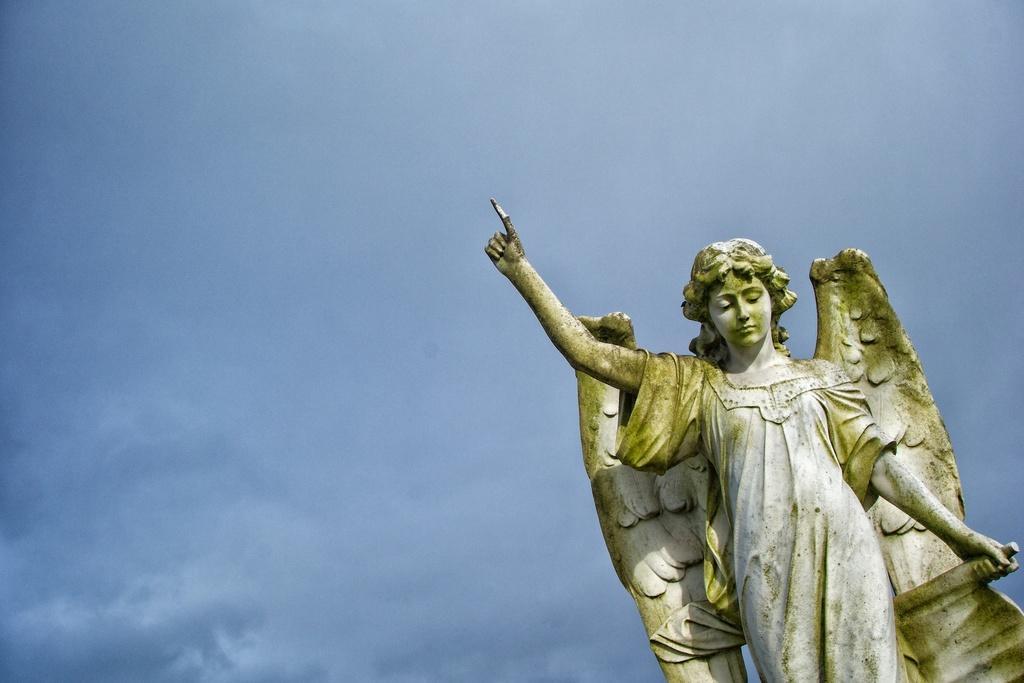Please provide a concise description of this image. In this image I can see the statue of the person which is in ash and green color. In the background I can see the blue sky. 